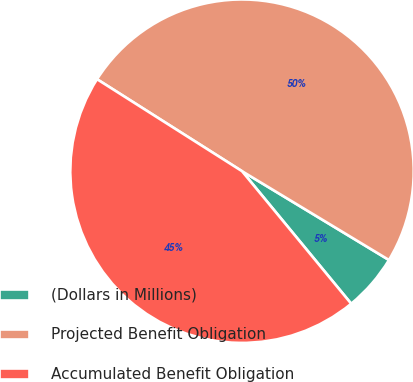Convert chart to OTSL. <chart><loc_0><loc_0><loc_500><loc_500><pie_chart><fcel>(Dollars in Millions)<fcel>Projected Benefit Obligation<fcel>Accumulated Benefit Obligation<nl><fcel>5.38%<fcel>49.65%<fcel>44.96%<nl></chart> 